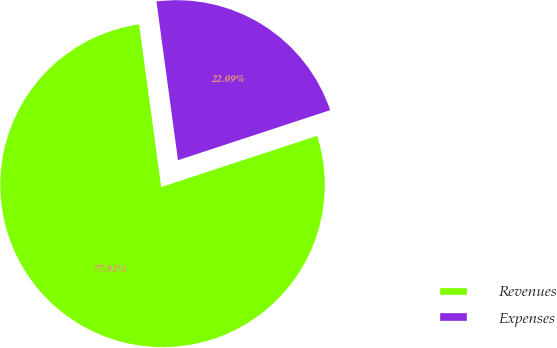<chart> <loc_0><loc_0><loc_500><loc_500><pie_chart><fcel>Revenues<fcel>Expenses<nl><fcel>77.91%<fcel>22.09%<nl></chart> 